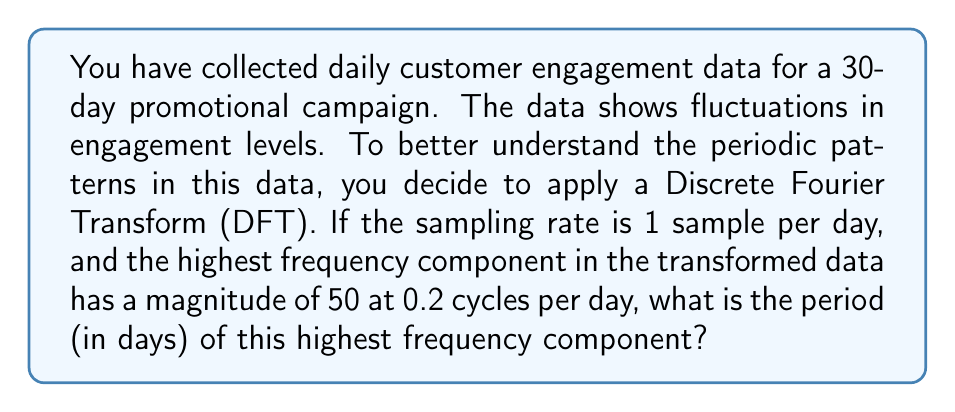Give your solution to this math problem. To solve this problem, we need to understand the relationship between frequency and period in the context of the Fourier Transform. Let's break it down step-by-step:

1) In the Fourier Transform, frequency is typically measured in cycles per sample. Here, we're given the frequency in cycles per day, which is equivalent since our sampling rate is 1 sample per day.

2) We're told that the highest frequency component is at 0.2 cycles per day.

3) The relationship between frequency (f) and period (T) is:

   $$T = \frac{1}{f}$$

4) Substituting our frequency:

   $$T = \frac{1}{0.2} \text{ days}$$

5) Calculating:

   $$T = 5 \text{ days}$$

This means that the highest frequency component in our customer engagement data repeats every 5 days.

Note: The magnitude of 50 given in the problem is not necessary for calculating the period, but it tells us that this 5-day cycle is a significant pattern in the data.
Answer: 5 days 